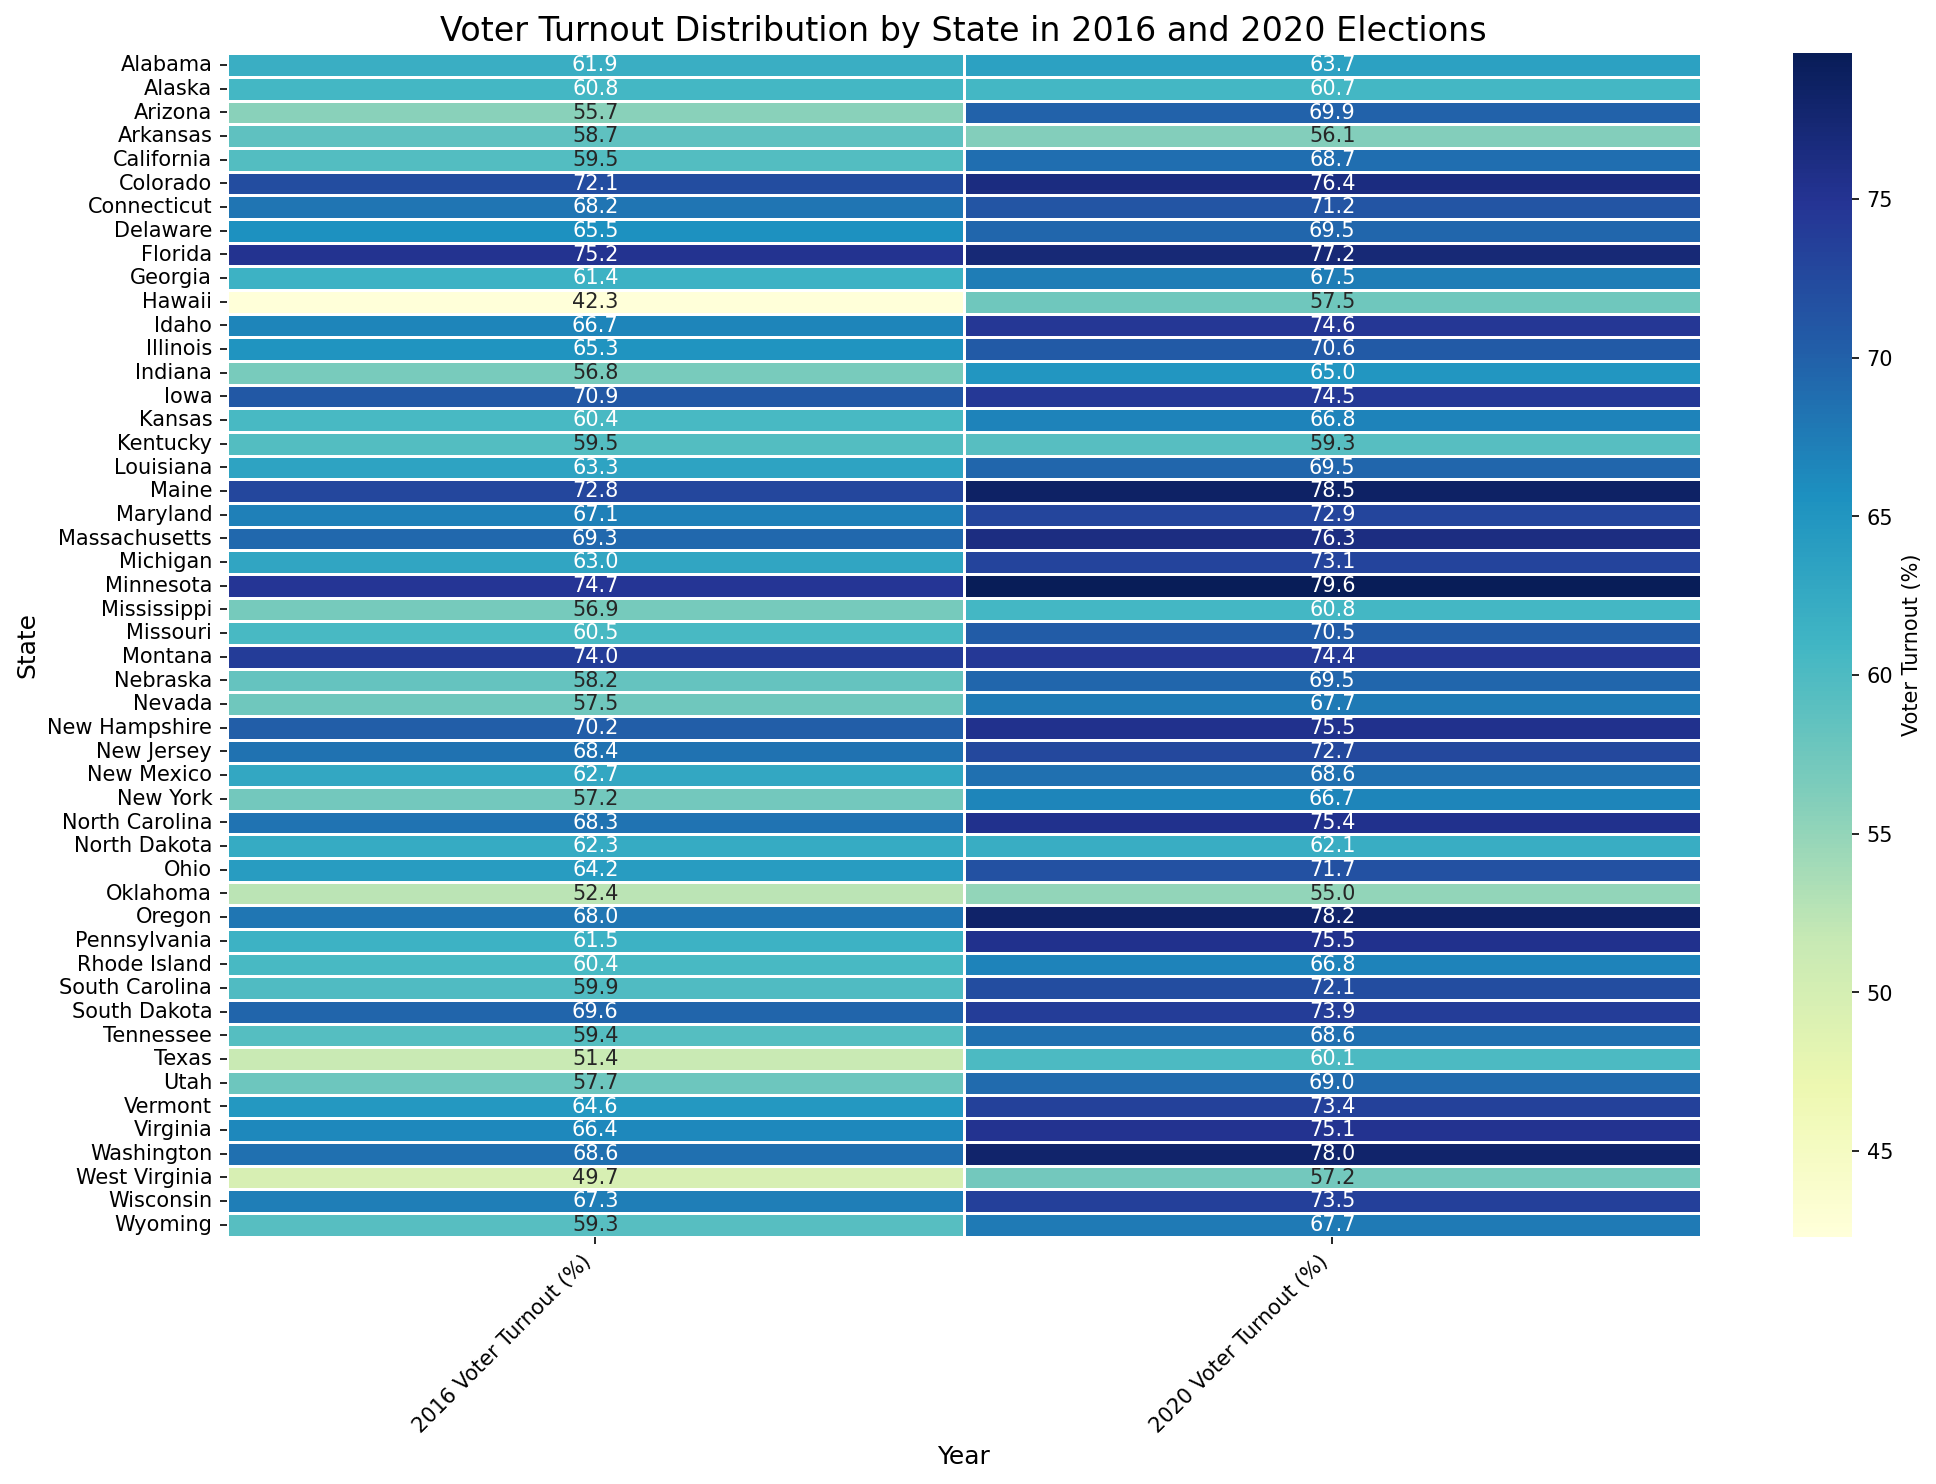Which state had the highest voter turnout in 2020? To find the state with the highest voter turnout in 2020, scan through the '2020 Voter Turnout (%)' column and identify the highest value. The highest value, 79.6%, corresponds to Minnesota.
Answer: Minnesota How much did voter turnout increase in Arizona from 2016 to 2020? To calculate the increase in voter turnout for Arizona, subtract the 2016 voter turnout from the 2020 voter turnout. For Arizona, it is 69.9% - 55.7% = 14.2%.
Answer: 14.2% Which state had the largest decrease in voter turnout from 2016 to 2020? Identify the states with decreases by comparing the '2016 Voter Turnout (%)' column to the '2020 Voter Turnout (%)' column, then find the one with the largest negative difference. Kentucky had the largest decrease: 59.5% in 2016 to 59.3% in 2020, a decrease of 0.2%.
Answer: Kentucky What was the average voter turnout across all states in 2016? To find the average voter turnout for 2016, sum all the voter turnout percentages for 2016 and divide by the number of states: (61.9 + 60.8 + 55.7 + ... + 67.3 + 59.3) / 51 = 62.04%.
Answer: 62.04% Compare the changes in voter turnout between Alabama and Georgia from 2016 to 2020. Calculate the change for Alabama and Georgia separately by subtracting the 2016 voter turnout from the 2020 voter turnout for each state: Alabama, 63.7% - 61.9% = 1.8%; Georgia, 67.5% - 61.4% = 6.1%. Georgia had a larger increase in turnout.
Answer: Georgia Which states had a voter turnout percentage above 70% in 2020? Scan the '2020 Voter Turnout (%)' column and identify all states with a turnout above 70%. These states are Colorado, Florida, Idaho, Iowa, Maine, Massachusetts, Michigan, Minnesota, Montana, New Hampshire, North Carolina, Ohio, Oregon, Pennsylvania, South Carolina, South Dakota, Virginia, Washington, and Wisconsin.
Answer: 19 states What is the difference in voter turnout between the highest and lowest states in 2016? Find the highest and lowest voter turnout values in 2016 and calculate the difference. The highest turnout is Minnesota at 74.7%, and the lowest is West Virginia at 49.7%; thus, the difference is 74.7% - 49.7% = 25%.
Answer: 25% Did voter turnout in New York improve or decline from 2016 to 2020? Compare the voter turnout percentages for New York in 2016 and 2020. New York's voter turnout increased from 57.2% in 2016 to 66.7% in 2020.
Answer: Improved Which state had below 50% voter turnout in 2016 but showed an increase in 2020? Check the '2016 Voter Turnout (%)' column for states below 50% and then see if their 2020 turnout increased. West Virginia had a turnout of 49.7% in 2016 and increased to 57.2% in 2020.
Answer: West Virginia 